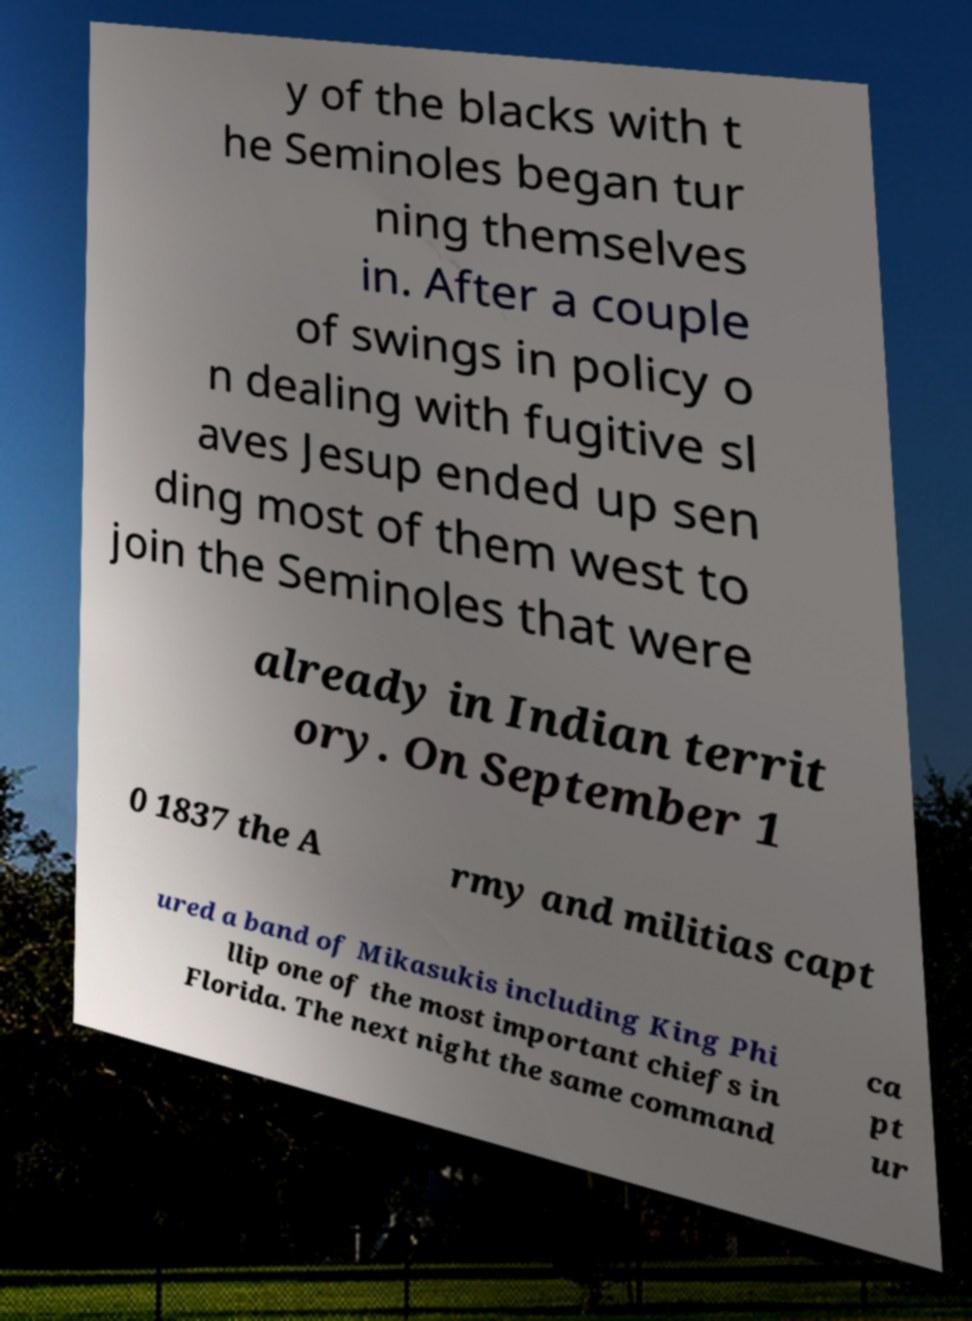Can you read and provide the text displayed in the image?This photo seems to have some interesting text. Can you extract and type it out for me? y of the blacks with t he Seminoles began tur ning themselves in. After a couple of swings in policy o n dealing with fugitive sl aves Jesup ended up sen ding most of them west to join the Seminoles that were already in Indian territ ory. On September 1 0 1837 the A rmy and militias capt ured a band of Mikasukis including King Phi llip one of the most important chiefs in Florida. The next night the same command ca pt ur 